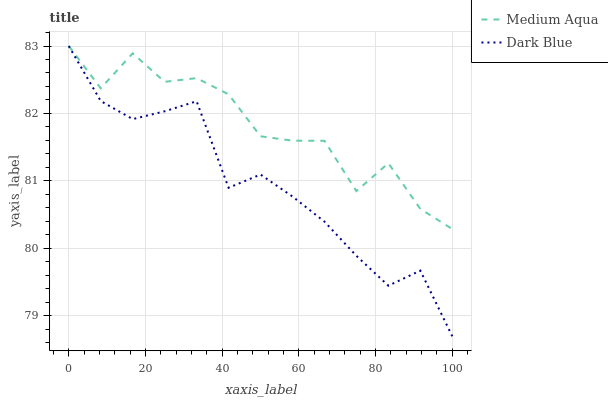Does Dark Blue have the minimum area under the curve?
Answer yes or no. Yes. Does Medium Aqua have the maximum area under the curve?
Answer yes or no. Yes. Does Medium Aqua have the minimum area under the curve?
Answer yes or no. No. Is Dark Blue the smoothest?
Answer yes or no. Yes. Is Medium Aqua the roughest?
Answer yes or no. Yes. Is Medium Aqua the smoothest?
Answer yes or no. No. Does Medium Aqua have the lowest value?
Answer yes or no. No. Does Medium Aqua have the highest value?
Answer yes or no. Yes. Does Dark Blue intersect Medium Aqua?
Answer yes or no. Yes. Is Dark Blue less than Medium Aqua?
Answer yes or no. No. Is Dark Blue greater than Medium Aqua?
Answer yes or no. No. 